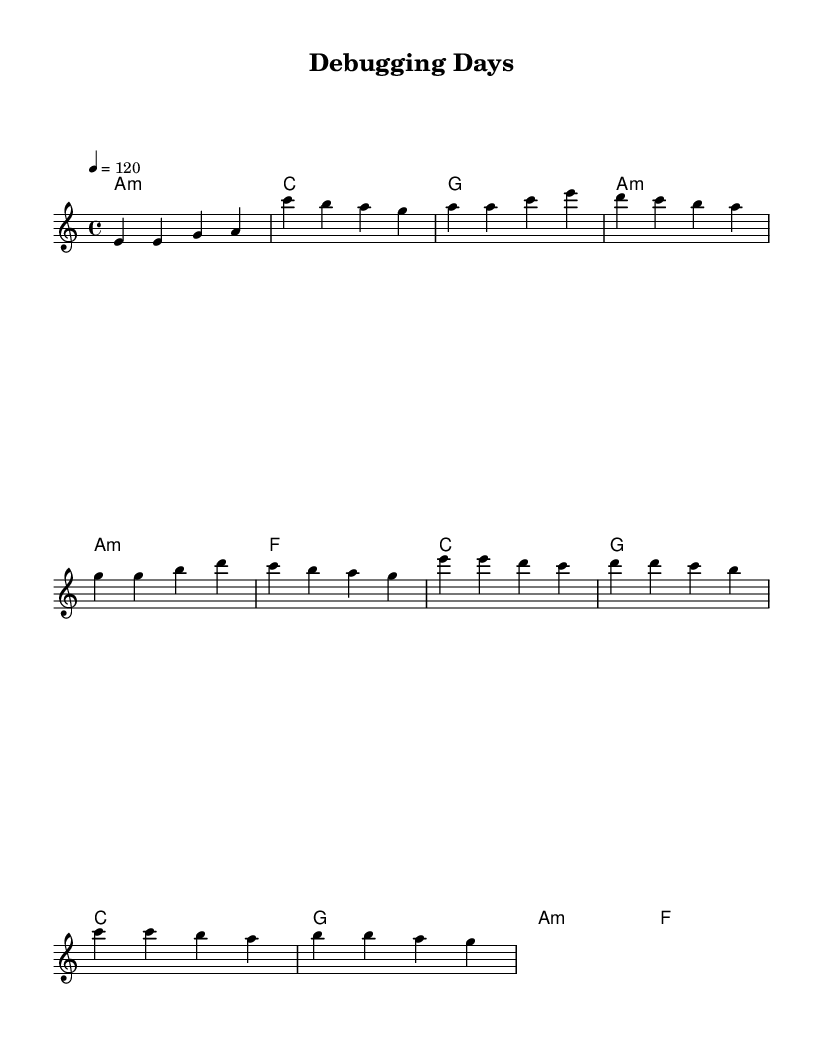What is the key signature of this music? The music is written in A minor, which has no sharps or flats and is indicated by the key signature at the beginning of the staff.
Answer: A minor What is the time signature of this music? The time signature is 4/4, as noted at the beginning of the score, which means there are four beats in each measure and the quarter note gets one beat.
Answer: 4/4 What is the tempo marking indicated in the sheet music? The tempo marking is set at a quarter note equals 120 beats per minute, typically found in the tempo instruction section.
Answer: 120 How many measures are in the chorus section? The chorus is composed of four measures, identified by counting the groupings of bars shown in the score.
Answer: Four Which chord is played during the first measure of the intro? The chord played in the first measure of the intro is an A minor chord, extracted from the chord section that denotes harmony with the melody.
Answer: A minor What is the overarching theme of the lyrics in this piece? The lyrics center around coding and problem-solving in the digital age, as illustrated by phrases such as "Lines of code" and references to debugging and Stack Overflow.
Answer: Coding What is the last line of the chorus lyrics? The last line of the chorus lyrics is "Coding is our way back home," which can be found at the end of the lyric section under the chorus part.
Answer: Coding is our way back home 